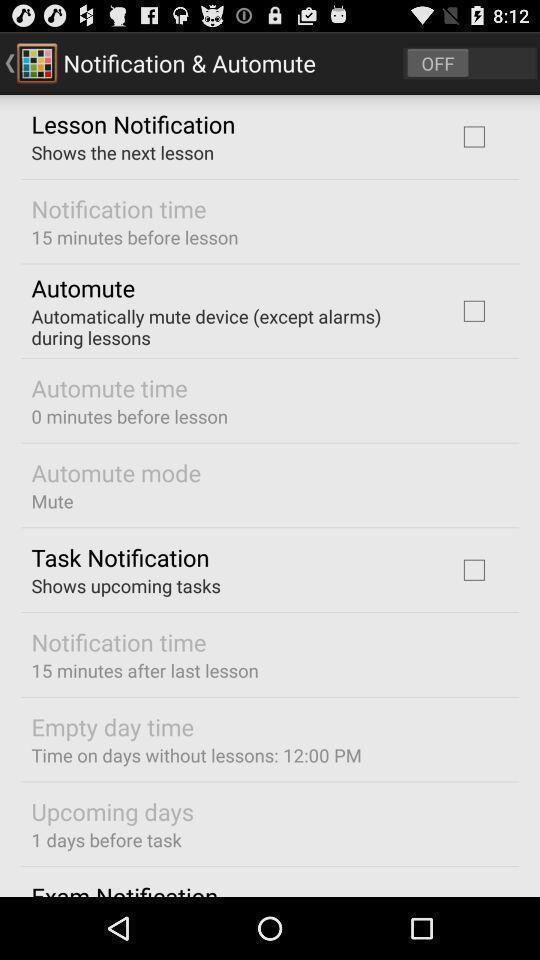Provide a description of this screenshot. Page displaying different options. 